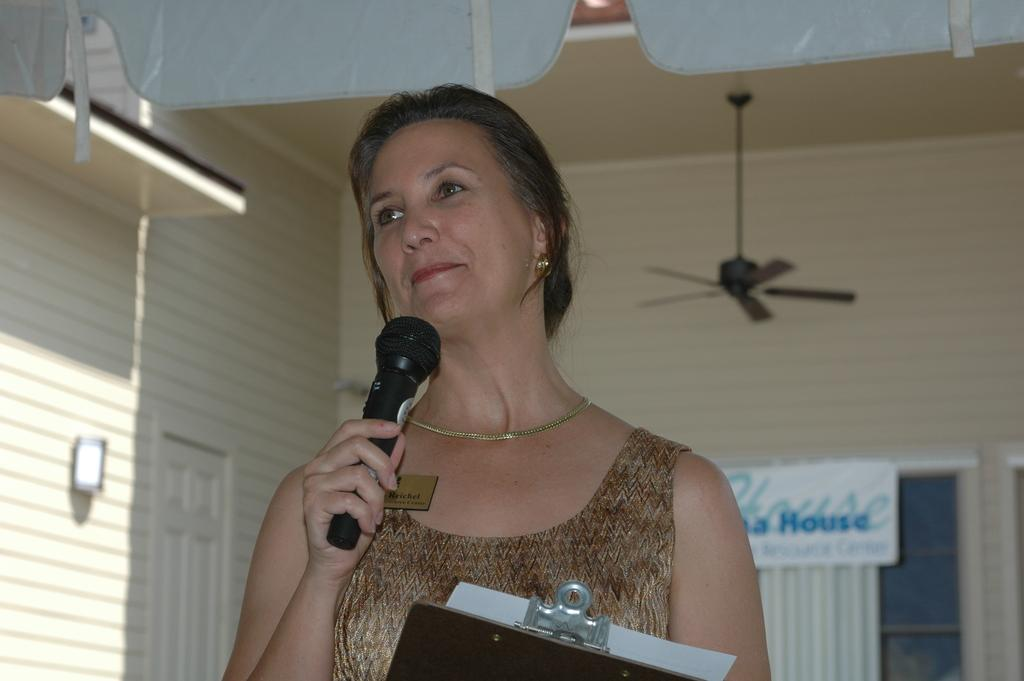What is the woman in the image holding? The woman is holding a mic and papers in her hand. What is the woman's facial expression in the image? The woman is smiling in the image. What can be seen in the background of the image? There is a fan and a wall in the background of the image. What type of hair product is the woman using in the image? There is no indication in the image that the woman is using any hair product. What is the woman protesting about in the image? There is no protest or cause mentioned in the image; the woman is simply holding a mic and papers. 